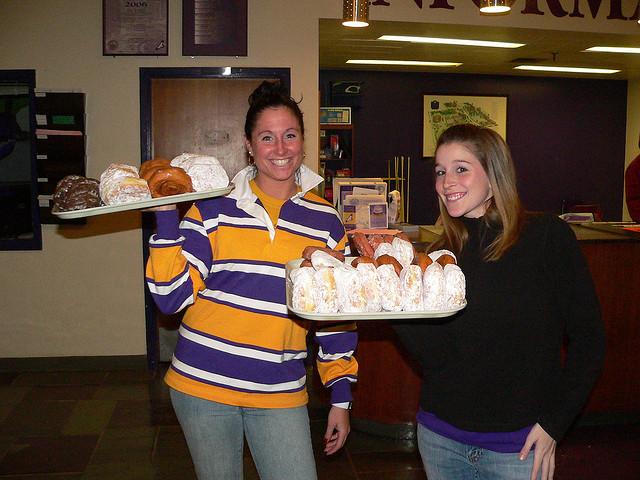Is the woman on the left wearing an attractive shirt?
Keep it brief. No. Are the people happy?
Answer briefly. Yes. Is the woman wearing a watch?
Keep it brief. Yes. Is this a supermarket?
Quick response, please. No. What are the girls holding?
Concise answer only. Donuts. Is she using a plate?
Write a very short answer. No. 